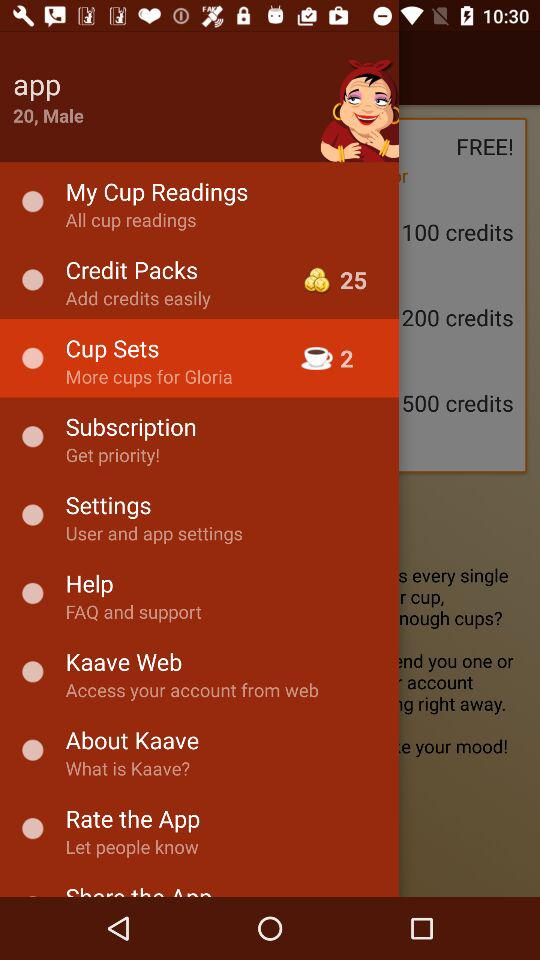For which item 2 cups are mentioned? The item is "Cup Sets". 